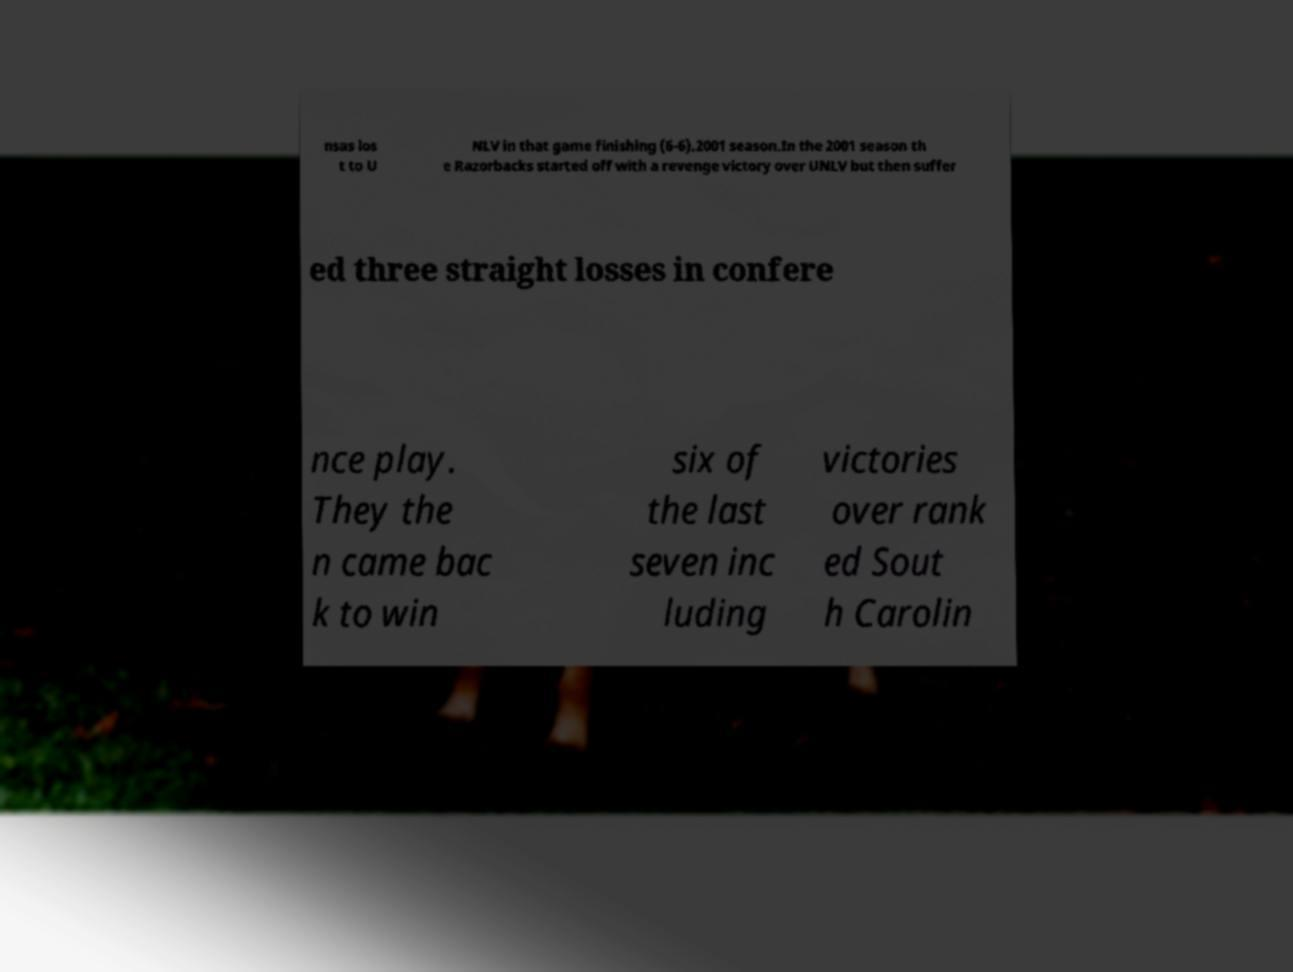There's text embedded in this image that I need extracted. Can you transcribe it verbatim? nsas los t to U NLV in that game finishing (6-6).2001 season.In the 2001 season th e Razorbacks started off with a revenge victory over UNLV but then suffer ed three straight losses in confere nce play. They the n came bac k to win six of the last seven inc luding victories over rank ed Sout h Carolin 